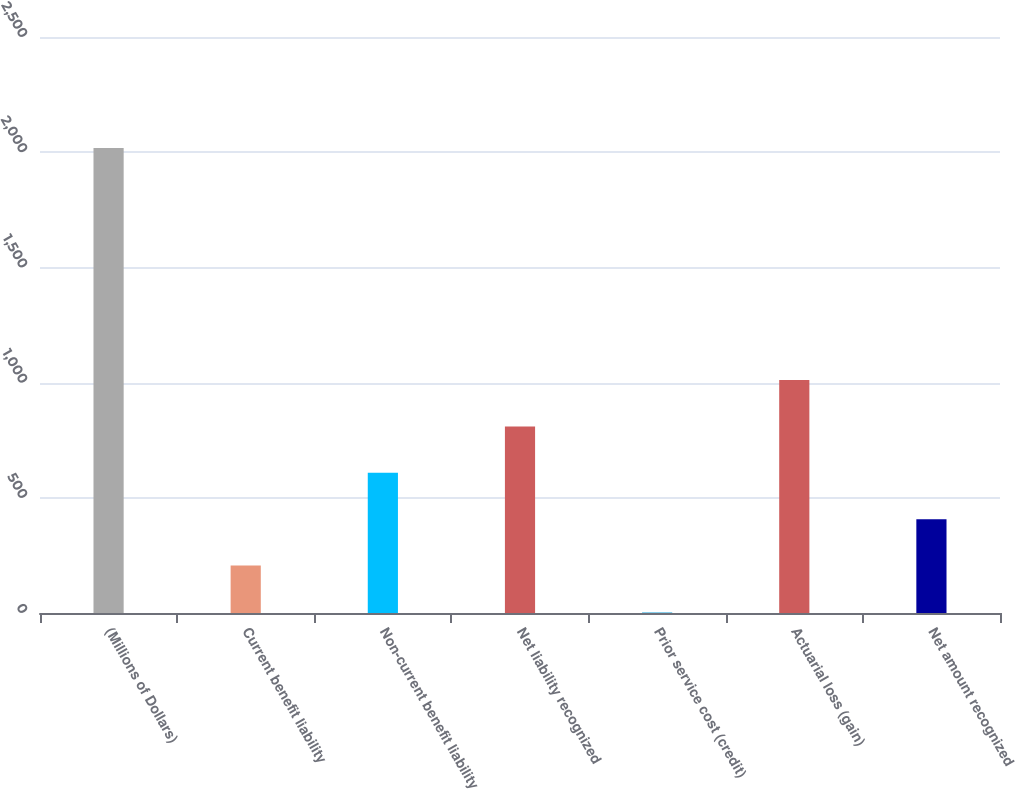Convert chart to OTSL. <chart><loc_0><loc_0><loc_500><loc_500><bar_chart><fcel>(Millions of Dollars)<fcel>Current benefit liability<fcel>Non-current benefit liability<fcel>Net liability recognized<fcel>Prior service cost (credit)<fcel>Actuarial loss (gain)<fcel>Net amount recognized<nl><fcel>2018<fcel>205.67<fcel>608.41<fcel>809.78<fcel>4.3<fcel>1011.15<fcel>407.04<nl></chart> 